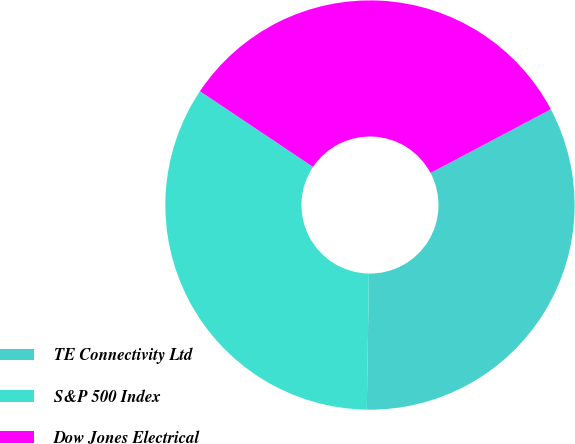Convert chart. <chart><loc_0><loc_0><loc_500><loc_500><pie_chart><fcel>TE Connectivity Ltd<fcel>S&P 500 Index<fcel>Dow Jones Electrical<nl><fcel>32.99%<fcel>34.14%<fcel>32.86%<nl></chart> 